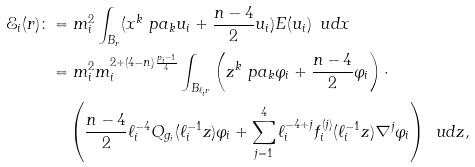<formula> <loc_0><loc_0><loc_500><loc_500>\mathcal { E } _ { i } ( r ) \colon & = m _ { i } ^ { 2 } \int _ { B _ { r } } ( x ^ { k } \ p a _ { k } u _ { i } + \frac { n - 4 } { 2 } u _ { i } ) E ( u _ { i } ) \, \ u d x \\ & = m _ { i } ^ { 2 } m _ { i } ^ { 2 + ( 4 - n ) \frac { p _ { i } - 1 } { 4 } } \int _ { B _ { \ell _ { i } r } } \left ( z ^ { k } \ p a _ { k } \varphi _ { i } + \frac { n - 4 } { 2 } \varphi _ { i } \right ) \cdot \\ & \quad \left ( \frac { n - 4 } { 2 } \ell _ { i } ^ { - 4 } Q _ { g _ { i } } ( \ell _ { i } ^ { - 1 } z ) \varphi _ { i } + \sum _ { j = 1 } ^ { 4 } \ell _ { i } ^ { - 4 + j } f _ { i } ^ { ( j ) } ( \ell _ { i } ^ { - 1 } z ) \nabla ^ { j } \varphi _ { i } \right ) \, \ u d z ,</formula> 